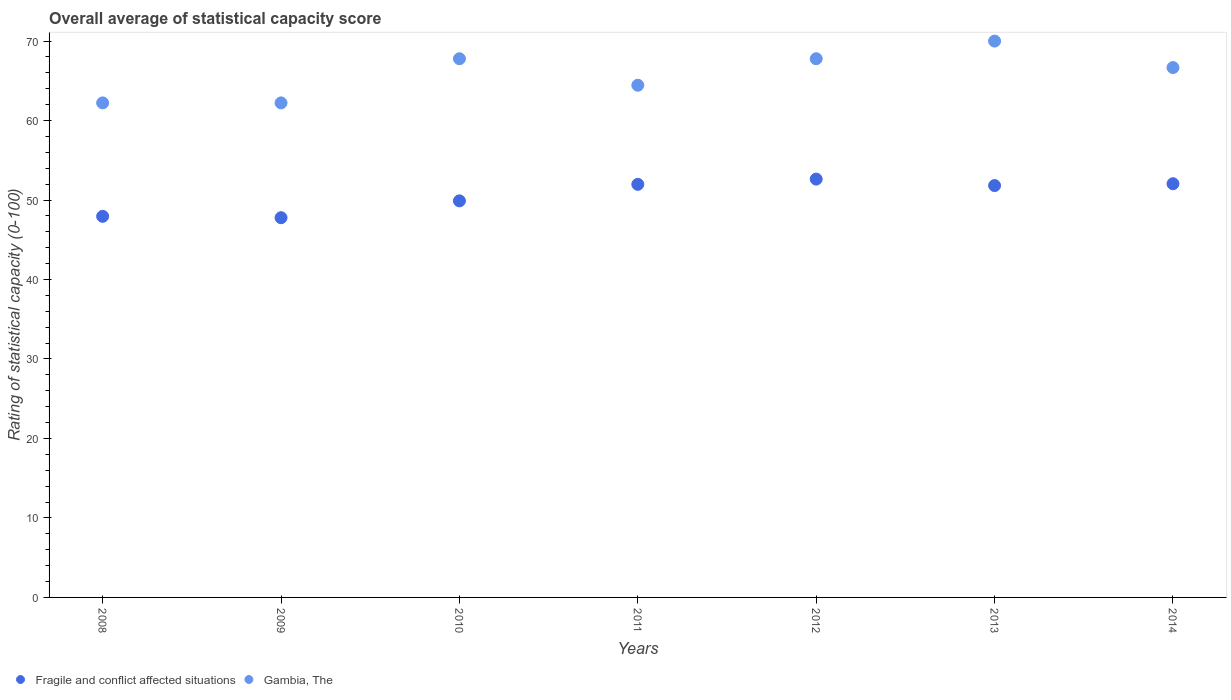Is the number of dotlines equal to the number of legend labels?
Your answer should be very brief. Yes. What is the rating of statistical capacity in Fragile and conflict affected situations in 2010?
Offer a terse response. 49.9. Across all years, what is the maximum rating of statistical capacity in Fragile and conflict affected situations?
Make the answer very short. 52.63. Across all years, what is the minimum rating of statistical capacity in Fragile and conflict affected situations?
Ensure brevity in your answer.  47.78. In which year was the rating of statistical capacity in Fragile and conflict affected situations maximum?
Offer a terse response. 2012. In which year was the rating of statistical capacity in Gambia, The minimum?
Provide a succinct answer. 2008. What is the total rating of statistical capacity in Gambia, The in the graph?
Offer a very short reply. 461.11. What is the difference between the rating of statistical capacity in Fragile and conflict affected situations in 2009 and that in 2010?
Give a very brief answer. -2.12. What is the difference between the rating of statistical capacity in Fragile and conflict affected situations in 2014 and the rating of statistical capacity in Gambia, The in 2009?
Give a very brief answer. -10.17. What is the average rating of statistical capacity in Fragile and conflict affected situations per year?
Your response must be concise. 50.59. In the year 2009, what is the difference between the rating of statistical capacity in Gambia, The and rating of statistical capacity in Fragile and conflict affected situations?
Provide a short and direct response. 14.44. What is the ratio of the rating of statistical capacity in Gambia, The in 2009 to that in 2011?
Your answer should be compact. 0.97. Is the difference between the rating of statistical capacity in Gambia, The in 2008 and 2014 greater than the difference between the rating of statistical capacity in Fragile and conflict affected situations in 2008 and 2014?
Offer a very short reply. No. What is the difference between the highest and the second highest rating of statistical capacity in Fragile and conflict affected situations?
Make the answer very short. 0.58. What is the difference between the highest and the lowest rating of statistical capacity in Fragile and conflict affected situations?
Make the answer very short. 4.86. Does the rating of statistical capacity in Fragile and conflict affected situations monotonically increase over the years?
Offer a very short reply. No. Is the rating of statistical capacity in Gambia, The strictly less than the rating of statistical capacity in Fragile and conflict affected situations over the years?
Keep it short and to the point. No. How many dotlines are there?
Provide a succinct answer. 2. How many years are there in the graph?
Your answer should be compact. 7. What is the difference between two consecutive major ticks on the Y-axis?
Give a very brief answer. 10. Does the graph contain any zero values?
Offer a terse response. No. Does the graph contain grids?
Your answer should be very brief. No. Where does the legend appear in the graph?
Provide a succinct answer. Bottom left. How many legend labels are there?
Keep it short and to the point. 2. What is the title of the graph?
Offer a terse response. Overall average of statistical capacity score. Does "Cambodia" appear as one of the legend labels in the graph?
Make the answer very short. No. What is the label or title of the Y-axis?
Your answer should be compact. Rating of statistical capacity (0-100). What is the Rating of statistical capacity (0-100) in Fragile and conflict affected situations in 2008?
Ensure brevity in your answer.  47.95. What is the Rating of statistical capacity (0-100) in Gambia, The in 2008?
Offer a terse response. 62.22. What is the Rating of statistical capacity (0-100) in Fragile and conflict affected situations in 2009?
Your answer should be compact. 47.78. What is the Rating of statistical capacity (0-100) in Gambia, The in 2009?
Provide a short and direct response. 62.22. What is the Rating of statistical capacity (0-100) in Fragile and conflict affected situations in 2010?
Offer a terse response. 49.9. What is the Rating of statistical capacity (0-100) in Gambia, The in 2010?
Give a very brief answer. 67.78. What is the Rating of statistical capacity (0-100) of Fragile and conflict affected situations in 2011?
Offer a very short reply. 51.98. What is the Rating of statistical capacity (0-100) of Gambia, The in 2011?
Offer a very short reply. 64.44. What is the Rating of statistical capacity (0-100) of Fragile and conflict affected situations in 2012?
Your answer should be compact. 52.63. What is the Rating of statistical capacity (0-100) in Gambia, The in 2012?
Offer a very short reply. 67.78. What is the Rating of statistical capacity (0-100) of Fragile and conflict affected situations in 2013?
Your answer should be very brief. 51.82. What is the Rating of statistical capacity (0-100) of Fragile and conflict affected situations in 2014?
Keep it short and to the point. 52.05. What is the Rating of statistical capacity (0-100) of Gambia, The in 2014?
Your answer should be compact. 66.67. Across all years, what is the maximum Rating of statistical capacity (0-100) of Fragile and conflict affected situations?
Offer a very short reply. 52.63. Across all years, what is the maximum Rating of statistical capacity (0-100) in Gambia, The?
Provide a short and direct response. 70. Across all years, what is the minimum Rating of statistical capacity (0-100) of Fragile and conflict affected situations?
Ensure brevity in your answer.  47.78. Across all years, what is the minimum Rating of statistical capacity (0-100) of Gambia, The?
Your answer should be very brief. 62.22. What is the total Rating of statistical capacity (0-100) in Fragile and conflict affected situations in the graph?
Provide a short and direct response. 354.1. What is the total Rating of statistical capacity (0-100) in Gambia, The in the graph?
Offer a very short reply. 461.11. What is the difference between the Rating of statistical capacity (0-100) of Fragile and conflict affected situations in 2008 and that in 2009?
Your response must be concise. 0.17. What is the difference between the Rating of statistical capacity (0-100) of Gambia, The in 2008 and that in 2009?
Your answer should be compact. 0. What is the difference between the Rating of statistical capacity (0-100) of Fragile and conflict affected situations in 2008 and that in 2010?
Offer a very short reply. -1.95. What is the difference between the Rating of statistical capacity (0-100) of Gambia, The in 2008 and that in 2010?
Your response must be concise. -5.56. What is the difference between the Rating of statistical capacity (0-100) of Fragile and conflict affected situations in 2008 and that in 2011?
Provide a short and direct response. -4.03. What is the difference between the Rating of statistical capacity (0-100) of Gambia, The in 2008 and that in 2011?
Make the answer very short. -2.22. What is the difference between the Rating of statistical capacity (0-100) of Fragile and conflict affected situations in 2008 and that in 2012?
Provide a succinct answer. -4.68. What is the difference between the Rating of statistical capacity (0-100) in Gambia, The in 2008 and that in 2012?
Keep it short and to the point. -5.56. What is the difference between the Rating of statistical capacity (0-100) of Fragile and conflict affected situations in 2008 and that in 2013?
Your response must be concise. -3.87. What is the difference between the Rating of statistical capacity (0-100) in Gambia, The in 2008 and that in 2013?
Your response must be concise. -7.78. What is the difference between the Rating of statistical capacity (0-100) in Fragile and conflict affected situations in 2008 and that in 2014?
Keep it short and to the point. -4.1. What is the difference between the Rating of statistical capacity (0-100) of Gambia, The in 2008 and that in 2014?
Offer a very short reply. -4.44. What is the difference between the Rating of statistical capacity (0-100) in Fragile and conflict affected situations in 2009 and that in 2010?
Offer a terse response. -2.12. What is the difference between the Rating of statistical capacity (0-100) of Gambia, The in 2009 and that in 2010?
Your answer should be very brief. -5.56. What is the difference between the Rating of statistical capacity (0-100) in Fragile and conflict affected situations in 2009 and that in 2011?
Ensure brevity in your answer.  -4.2. What is the difference between the Rating of statistical capacity (0-100) of Gambia, The in 2009 and that in 2011?
Offer a very short reply. -2.22. What is the difference between the Rating of statistical capacity (0-100) of Fragile and conflict affected situations in 2009 and that in 2012?
Provide a succinct answer. -4.86. What is the difference between the Rating of statistical capacity (0-100) of Gambia, The in 2009 and that in 2012?
Provide a short and direct response. -5.56. What is the difference between the Rating of statistical capacity (0-100) of Fragile and conflict affected situations in 2009 and that in 2013?
Give a very brief answer. -4.04. What is the difference between the Rating of statistical capacity (0-100) in Gambia, The in 2009 and that in 2013?
Provide a succinct answer. -7.78. What is the difference between the Rating of statistical capacity (0-100) of Fragile and conflict affected situations in 2009 and that in 2014?
Your answer should be compact. -4.27. What is the difference between the Rating of statistical capacity (0-100) of Gambia, The in 2009 and that in 2014?
Ensure brevity in your answer.  -4.44. What is the difference between the Rating of statistical capacity (0-100) of Fragile and conflict affected situations in 2010 and that in 2011?
Your answer should be very brief. -2.08. What is the difference between the Rating of statistical capacity (0-100) of Gambia, The in 2010 and that in 2011?
Keep it short and to the point. 3.33. What is the difference between the Rating of statistical capacity (0-100) in Fragile and conflict affected situations in 2010 and that in 2012?
Provide a short and direct response. -2.74. What is the difference between the Rating of statistical capacity (0-100) in Gambia, The in 2010 and that in 2012?
Your answer should be very brief. 0. What is the difference between the Rating of statistical capacity (0-100) of Fragile and conflict affected situations in 2010 and that in 2013?
Your answer should be compact. -1.92. What is the difference between the Rating of statistical capacity (0-100) in Gambia, The in 2010 and that in 2013?
Ensure brevity in your answer.  -2.22. What is the difference between the Rating of statistical capacity (0-100) in Fragile and conflict affected situations in 2010 and that in 2014?
Give a very brief answer. -2.15. What is the difference between the Rating of statistical capacity (0-100) in Gambia, The in 2010 and that in 2014?
Provide a succinct answer. 1.11. What is the difference between the Rating of statistical capacity (0-100) of Fragile and conflict affected situations in 2011 and that in 2012?
Provide a short and direct response. -0.66. What is the difference between the Rating of statistical capacity (0-100) in Fragile and conflict affected situations in 2011 and that in 2013?
Your answer should be compact. 0.16. What is the difference between the Rating of statistical capacity (0-100) in Gambia, The in 2011 and that in 2013?
Keep it short and to the point. -5.56. What is the difference between the Rating of statistical capacity (0-100) of Fragile and conflict affected situations in 2011 and that in 2014?
Provide a short and direct response. -0.07. What is the difference between the Rating of statistical capacity (0-100) in Gambia, The in 2011 and that in 2014?
Offer a very short reply. -2.22. What is the difference between the Rating of statistical capacity (0-100) of Fragile and conflict affected situations in 2012 and that in 2013?
Ensure brevity in your answer.  0.81. What is the difference between the Rating of statistical capacity (0-100) in Gambia, The in 2012 and that in 2013?
Provide a succinct answer. -2.22. What is the difference between the Rating of statistical capacity (0-100) of Fragile and conflict affected situations in 2012 and that in 2014?
Offer a terse response. 0.58. What is the difference between the Rating of statistical capacity (0-100) in Fragile and conflict affected situations in 2013 and that in 2014?
Give a very brief answer. -0.23. What is the difference between the Rating of statistical capacity (0-100) of Gambia, The in 2013 and that in 2014?
Provide a short and direct response. 3.33. What is the difference between the Rating of statistical capacity (0-100) in Fragile and conflict affected situations in 2008 and the Rating of statistical capacity (0-100) in Gambia, The in 2009?
Give a very brief answer. -14.27. What is the difference between the Rating of statistical capacity (0-100) in Fragile and conflict affected situations in 2008 and the Rating of statistical capacity (0-100) in Gambia, The in 2010?
Provide a short and direct response. -19.83. What is the difference between the Rating of statistical capacity (0-100) of Fragile and conflict affected situations in 2008 and the Rating of statistical capacity (0-100) of Gambia, The in 2011?
Ensure brevity in your answer.  -16.5. What is the difference between the Rating of statistical capacity (0-100) in Fragile and conflict affected situations in 2008 and the Rating of statistical capacity (0-100) in Gambia, The in 2012?
Make the answer very short. -19.83. What is the difference between the Rating of statistical capacity (0-100) in Fragile and conflict affected situations in 2008 and the Rating of statistical capacity (0-100) in Gambia, The in 2013?
Offer a very short reply. -22.05. What is the difference between the Rating of statistical capacity (0-100) of Fragile and conflict affected situations in 2008 and the Rating of statistical capacity (0-100) of Gambia, The in 2014?
Keep it short and to the point. -18.72. What is the difference between the Rating of statistical capacity (0-100) of Fragile and conflict affected situations in 2009 and the Rating of statistical capacity (0-100) of Gambia, The in 2011?
Your answer should be very brief. -16.67. What is the difference between the Rating of statistical capacity (0-100) of Fragile and conflict affected situations in 2009 and the Rating of statistical capacity (0-100) of Gambia, The in 2012?
Offer a terse response. -20. What is the difference between the Rating of statistical capacity (0-100) in Fragile and conflict affected situations in 2009 and the Rating of statistical capacity (0-100) in Gambia, The in 2013?
Ensure brevity in your answer.  -22.22. What is the difference between the Rating of statistical capacity (0-100) of Fragile and conflict affected situations in 2009 and the Rating of statistical capacity (0-100) of Gambia, The in 2014?
Your response must be concise. -18.89. What is the difference between the Rating of statistical capacity (0-100) in Fragile and conflict affected situations in 2010 and the Rating of statistical capacity (0-100) in Gambia, The in 2011?
Give a very brief answer. -14.55. What is the difference between the Rating of statistical capacity (0-100) of Fragile and conflict affected situations in 2010 and the Rating of statistical capacity (0-100) of Gambia, The in 2012?
Offer a terse response. -17.88. What is the difference between the Rating of statistical capacity (0-100) of Fragile and conflict affected situations in 2010 and the Rating of statistical capacity (0-100) of Gambia, The in 2013?
Make the answer very short. -20.1. What is the difference between the Rating of statistical capacity (0-100) of Fragile and conflict affected situations in 2010 and the Rating of statistical capacity (0-100) of Gambia, The in 2014?
Give a very brief answer. -16.77. What is the difference between the Rating of statistical capacity (0-100) of Fragile and conflict affected situations in 2011 and the Rating of statistical capacity (0-100) of Gambia, The in 2012?
Your answer should be compact. -15.8. What is the difference between the Rating of statistical capacity (0-100) of Fragile and conflict affected situations in 2011 and the Rating of statistical capacity (0-100) of Gambia, The in 2013?
Provide a succinct answer. -18.02. What is the difference between the Rating of statistical capacity (0-100) of Fragile and conflict affected situations in 2011 and the Rating of statistical capacity (0-100) of Gambia, The in 2014?
Give a very brief answer. -14.69. What is the difference between the Rating of statistical capacity (0-100) of Fragile and conflict affected situations in 2012 and the Rating of statistical capacity (0-100) of Gambia, The in 2013?
Give a very brief answer. -17.37. What is the difference between the Rating of statistical capacity (0-100) in Fragile and conflict affected situations in 2012 and the Rating of statistical capacity (0-100) in Gambia, The in 2014?
Ensure brevity in your answer.  -14.03. What is the difference between the Rating of statistical capacity (0-100) in Fragile and conflict affected situations in 2013 and the Rating of statistical capacity (0-100) in Gambia, The in 2014?
Offer a very short reply. -14.85. What is the average Rating of statistical capacity (0-100) of Fragile and conflict affected situations per year?
Your answer should be compact. 50.59. What is the average Rating of statistical capacity (0-100) in Gambia, The per year?
Offer a terse response. 65.87. In the year 2008, what is the difference between the Rating of statistical capacity (0-100) in Fragile and conflict affected situations and Rating of statistical capacity (0-100) in Gambia, The?
Make the answer very short. -14.27. In the year 2009, what is the difference between the Rating of statistical capacity (0-100) in Fragile and conflict affected situations and Rating of statistical capacity (0-100) in Gambia, The?
Offer a terse response. -14.44. In the year 2010, what is the difference between the Rating of statistical capacity (0-100) in Fragile and conflict affected situations and Rating of statistical capacity (0-100) in Gambia, The?
Give a very brief answer. -17.88. In the year 2011, what is the difference between the Rating of statistical capacity (0-100) of Fragile and conflict affected situations and Rating of statistical capacity (0-100) of Gambia, The?
Keep it short and to the point. -12.47. In the year 2012, what is the difference between the Rating of statistical capacity (0-100) in Fragile and conflict affected situations and Rating of statistical capacity (0-100) in Gambia, The?
Provide a succinct answer. -15.14. In the year 2013, what is the difference between the Rating of statistical capacity (0-100) of Fragile and conflict affected situations and Rating of statistical capacity (0-100) of Gambia, The?
Provide a succinct answer. -18.18. In the year 2014, what is the difference between the Rating of statistical capacity (0-100) of Fragile and conflict affected situations and Rating of statistical capacity (0-100) of Gambia, The?
Offer a terse response. -14.62. What is the ratio of the Rating of statistical capacity (0-100) in Gambia, The in 2008 to that in 2009?
Make the answer very short. 1. What is the ratio of the Rating of statistical capacity (0-100) of Gambia, The in 2008 to that in 2010?
Your answer should be very brief. 0.92. What is the ratio of the Rating of statistical capacity (0-100) in Fragile and conflict affected situations in 2008 to that in 2011?
Make the answer very short. 0.92. What is the ratio of the Rating of statistical capacity (0-100) of Gambia, The in 2008 to that in 2011?
Make the answer very short. 0.97. What is the ratio of the Rating of statistical capacity (0-100) in Fragile and conflict affected situations in 2008 to that in 2012?
Give a very brief answer. 0.91. What is the ratio of the Rating of statistical capacity (0-100) in Gambia, The in 2008 to that in 2012?
Offer a terse response. 0.92. What is the ratio of the Rating of statistical capacity (0-100) of Fragile and conflict affected situations in 2008 to that in 2013?
Your answer should be very brief. 0.93. What is the ratio of the Rating of statistical capacity (0-100) of Gambia, The in 2008 to that in 2013?
Ensure brevity in your answer.  0.89. What is the ratio of the Rating of statistical capacity (0-100) of Fragile and conflict affected situations in 2008 to that in 2014?
Offer a terse response. 0.92. What is the ratio of the Rating of statistical capacity (0-100) of Fragile and conflict affected situations in 2009 to that in 2010?
Provide a short and direct response. 0.96. What is the ratio of the Rating of statistical capacity (0-100) in Gambia, The in 2009 to that in 2010?
Keep it short and to the point. 0.92. What is the ratio of the Rating of statistical capacity (0-100) in Fragile and conflict affected situations in 2009 to that in 2011?
Provide a short and direct response. 0.92. What is the ratio of the Rating of statistical capacity (0-100) in Gambia, The in 2009 to that in 2011?
Offer a terse response. 0.97. What is the ratio of the Rating of statistical capacity (0-100) in Fragile and conflict affected situations in 2009 to that in 2012?
Keep it short and to the point. 0.91. What is the ratio of the Rating of statistical capacity (0-100) in Gambia, The in 2009 to that in 2012?
Your answer should be compact. 0.92. What is the ratio of the Rating of statistical capacity (0-100) in Fragile and conflict affected situations in 2009 to that in 2013?
Your response must be concise. 0.92. What is the ratio of the Rating of statistical capacity (0-100) of Gambia, The in 2009 to that in 2013?
Give a very brief answer. 0.89. What is the ratio of the Rating of statistical capacity (0-100) of Fragile and conflict affected situations in 2009 to that in 2014?
Provide a short and direct response. 0.92. What is the ratio of the Rating of statistical capacity (0-100) of Fragile and conflict affected situations in 2010 to that in 2011?
Provide a succinct answer. 0.96. What is the ratio of the Rating of statistical capacity (0-100) in Gambia, The in 2010 to that in 2011?
Provide a short and direct response. 1.05. What is the ratio of the Rating of statistical capacity (0-100) in Fragile and conflict affected situations in 2010 to that in 2012?
Provide a short and direct response. 0.95. What is the ratio of the Rating of statistical capacity (0-100) in Fragile and conflict affected situations in 2010 to that in 2013?
Provide a short and direct response. 0.96. What is the ratio of the Rating of statistical capacity (0-100) of Gambia, The in 2010 to that in 2013?
Your response must be concise. 0.97. What is the ratio of the Rating of statistical capacity (0-100) in Fragile and conflict affected situations in 2010 to that in 2014?
Your answer should be compact. 0.96. What is the ratio of the Rating of statistical capacity (0-100) of Gambia, The in 2010 to that in 2014?
Offer a terse response. 1.02. What is the ratio of the Rating of statistical capacity (0-100) in Fragile and conflict affected situations in 2011 to that in 2012?
Provide a succinct answer. 0.99. What is the ratio of the Rating of statistical capacity (0-100) in Gambia, The in 2011 to that in 2012?
Offer a very short reply. 0.95. What is the ratio of the Rating of statistical capacity (0-100) in Fragile and conflict affected situations in 2011 to that in 2013?
Give a very brief answer. 1. What is the ratio of the Rating of statistical capacity (0-100) in Gambia, The in 2011 to that in 2013?
Offer a very short reply. 0.92. What is the ratio of the Rating of statistical capacity (0-100) of Gambia, The in 2011 to that in 2014?
Give a very brief answer. 0.97. What is the ratio of the Rating of statistical capacity (0-100) of Fragile and conflict affected situations in 2012 to that in 2013?
Provide a short and direct response. 1.02. What is the ratio of the Rating of statistical capacity (0-100) in Gambia, The in 2012 to that in 2013?
Ensure brevity in your answer.  0.97. What is the ratio of the Rating of statistical capacity (0-100) of Fragile and conflict affected situations in 2012 to that in 2014?
Your answer should be very brief. 1.01. What is the ratio of the Rating of statistical capacity (0-100) of Gambia, The in 2012 to that in 2014?
Keep it short and to the point. 1.02. What is the ratio of the Rating of statistical capacity (0-100) of Fragile and conflict affected situations in 2013 to that in 2014?
Your response must be concise. 1. What is the ratio of the Rating of statistical capacity (0-100) in Gambia, The in 2013 to that in 2014?
Your answer should be very brief. 1.05. What is the difference between the highest and the second highest Rating of statistical capacity (0-100) of Fragile and conflict affected situations?
Give a very brief answer. 0.58. What is the difference between the highest and the second highest Rating of statistical capacity (0-100) in Gambia, The?
Keep it short and to the point. 2.22. What is the difference between the highest and the lowest Rating of statistical capacity (0-100) in Fragile and conflict affected situations?
Ensure brevity in your answer.  4.86. What is the difference between the highest and the lowest Rating of statistical capacity (0-100) of Gambia, The?
Give a very brief answer. 7.78. 